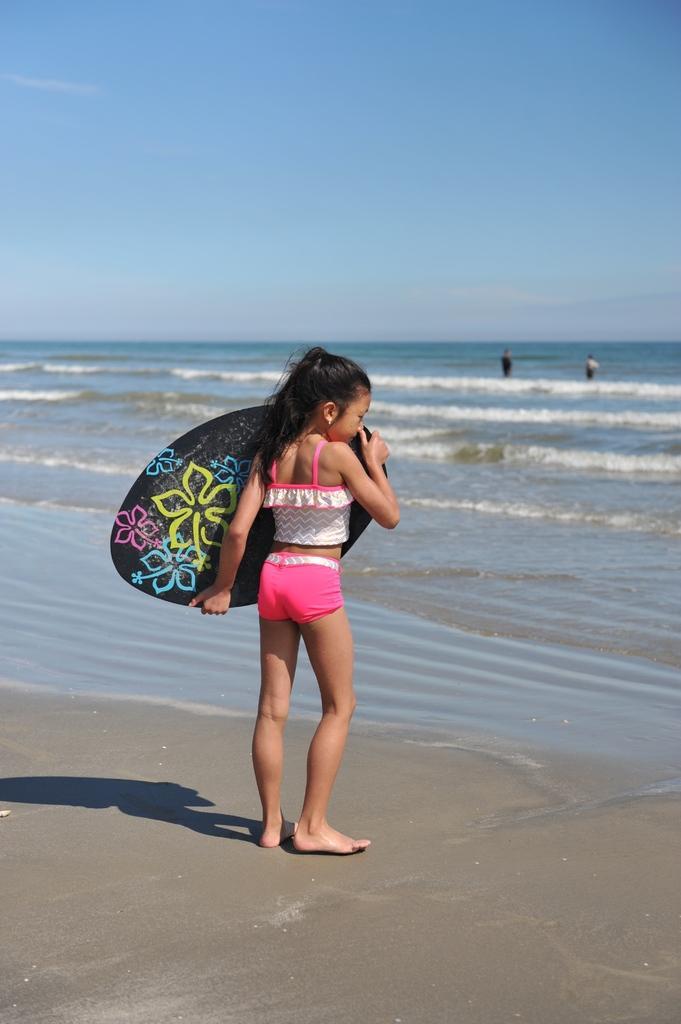Could you give a brief overview of what you see in this image? As we can see in the image there is a sky, water, three people and the girl who is standing here is holding surfboard. 